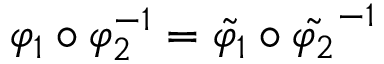Convert formula to latex. <formula><loc_0><loc_0><loc_500><loc_500>\varphi _ { 1 } \circ \varphi _ { 2 } ^ { - 1 } = \tilde { \varphi _ { 1 } } \circ \tilde { \varphi _ { 2 } } ^ { - 1 }</formula> 